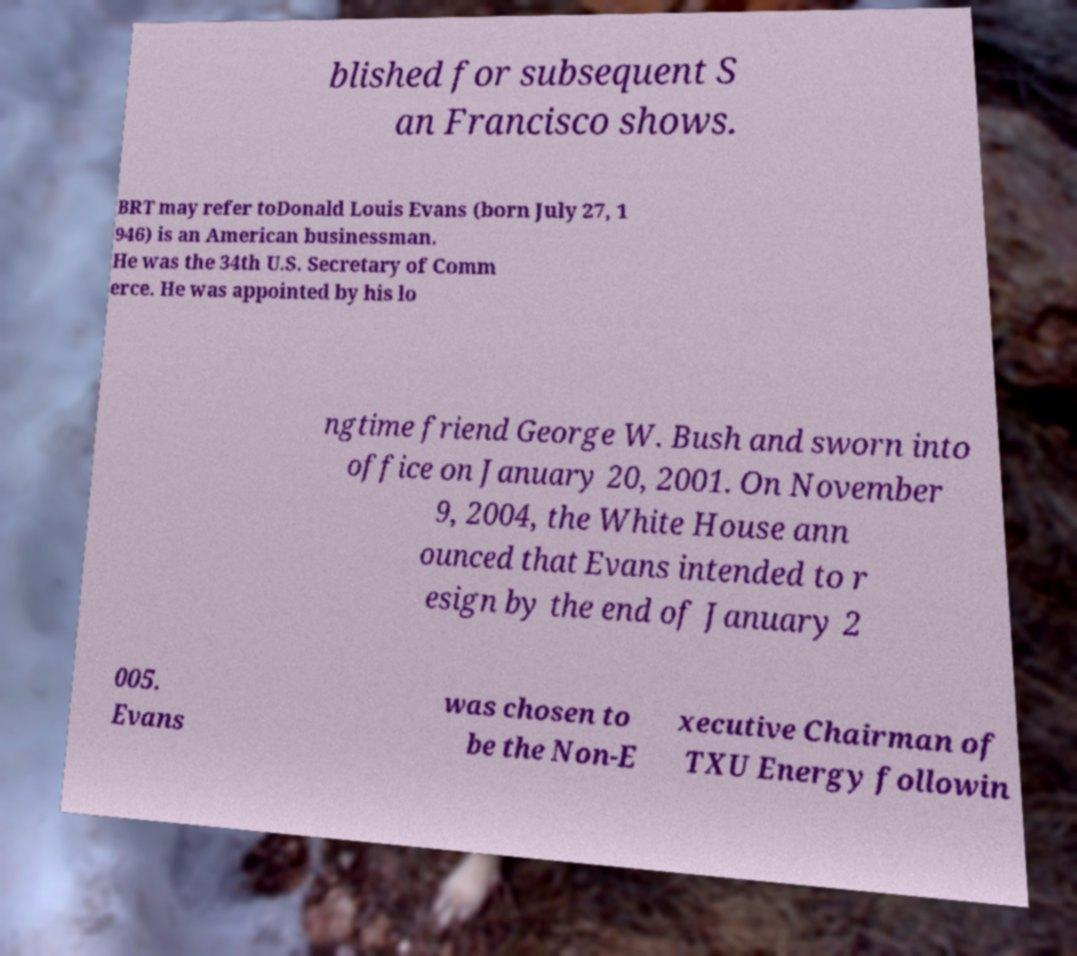Please identify and transcribe the text found in this image. blished for subsequent S an Francisco shows. BRT may refer toDonald Louis Evans (born July 27, 1 946) is an American businessman. He was the 34th U.S. Secretary of Comm erce. He was appointed by his lo ngtime friend George W. Bush and sworn into office on January 20, 2001. On November 9, 2004, the White House ann ounced that Evans intended to r esign by the end of January 2 005. Evans was chosen to be the Non-E xecutive Chairman of TXU Energy followin 